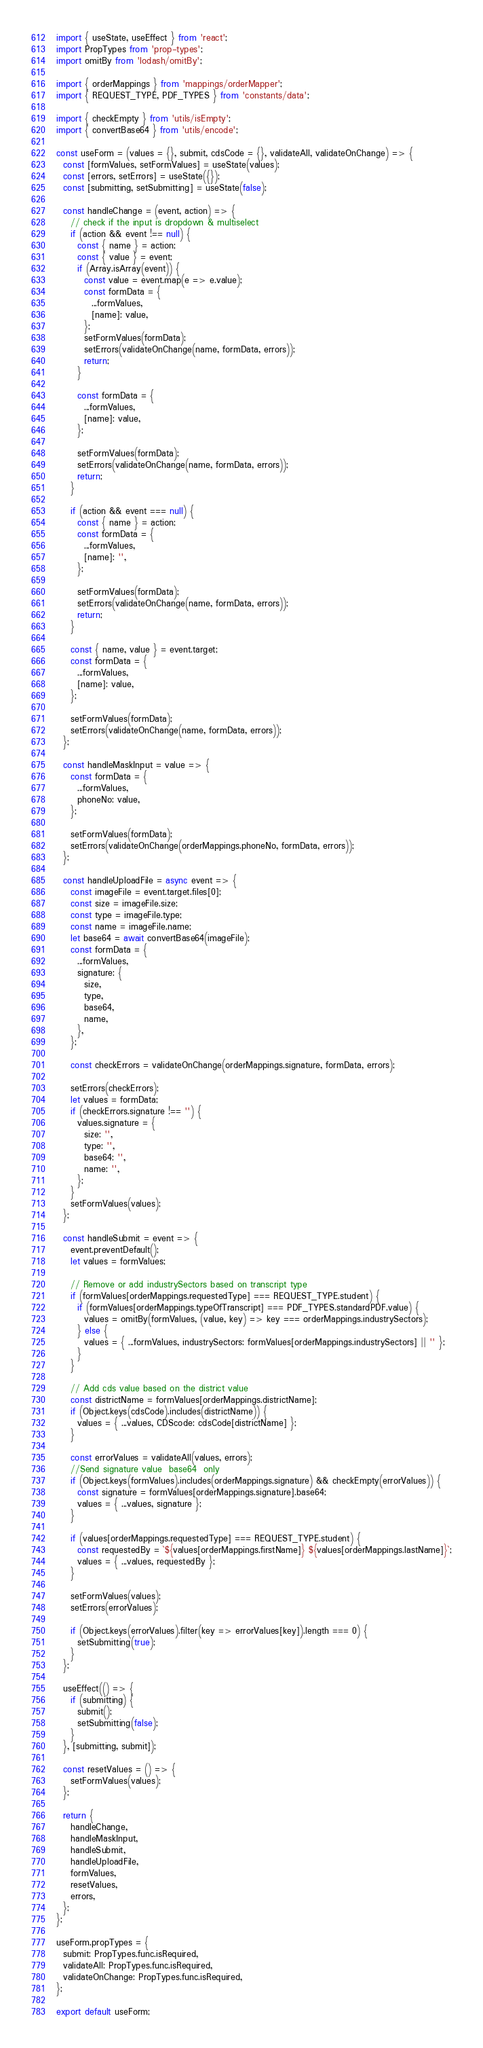Convert code to text. <code><loc_0><loc_0><loc_500><loc_500><_JavaScript_>import { useState, useEffect } from 'react';
import PropTypes from 'prop-types';
import omitBy from 'lodash/omitBy';

import { orderMappings } from 'mappings/orderMapper';
import { REQUEST_TYPE, PDF_TYPES } from 'constants/data';

import { checkEmpty } from 'utils/isEmpty';
import { convertBase64 } from 'utils/encode';

const useForm = (values = {}, submit, cdsCode = {}, validateAll, validateOnChange) => {
  const [formValues, setFormValues] = useState(values);
  const [errors, setErrors] = useState({});
  const [submitting, setSubmitting] = useState(false);

  const handleChange = (event, action) => {
    // check if the input is dropdown & multiselect
    if (action && event !== null) {
      const { name } = action;
      const { value } = event;
      if (Array.isArray(event)) {
        const value = event.map(e => e.value);
        const formData = {
          ...formValues,
          [name]: value,
        };
        setFormValues(formData);
        setErrors(validateOnChange(name, formData, errors));
        return;
      }

      const formData = {
        ...formValues,
        [name]: value,
      };

      setFormValues(formData);
      setErrors(validateOnChange(name, formData, errors));
      return;
    }

    if (action && event === null) {
      const { name } = action;
      const formData = {
        ...formValues,
        [name]: '',
      };

      setFormValues(formData);
      setErrors(validateOnChange(name, formData, errors));
      return;
    }

    const { name, value } = event.target;
    const formData = {
      ...formValues,
      [name]: value,
    };

    setFormValues(formData);
    setErrors(validateOnChange(name, formData, errors));
  };

  const handleMaskInput = value => {
    const formData = {
      ...formValues,
      phoneNo: value,
    };

    setFormValues(formData);
    setErrors(validateOnChange(orderMappings.phoneNo, formData, errors));
  };

  const handleUploadFile = async event => {
    const imageFile = event.target.files[0];
    const size = imageFile.size;
    const type = imageFile.type;
    const name = imageFile.name;
    let base64 = await convertBase64(imageFile);
    const formData = {
      ...formValues,
      signature: {
        size,
        type,
        base64,
        name,
      },
    };

    const checkErrors = validateOnChange(orderMappings.signature, formData, errors);

    setErrors(checkErrors);
    let values = formData;
    if (checkErrors.signature !== '') {
      values.signature = {
        size: '',
        type: '',
        base64: '',
        name: '',
      };
    }
    setFormValues(values);
  };

  const handleSubmit = event => {
    event.preventDefault();
    let values = formValues;

    // Remove or add industrySectors based on transcript type
    if (formValues[orderMappings.requestedType] === REQUEST_TYPE.student) {
      if (formValues[orderMappings.typeOfTranscript] === PDF_TYPES.standardPDF.value) {
        values = omitBy(formValues, (value, key) => key === orderMappings.industrySectors);
      } else {
        values = { ...formValues, industrySectors: formValues[orderMappings.industrySectors] || '' };
      }
    }

    // Add cds value based on the district value
    const districtName = formValues[orderMappings.districtName];
    if (Object.keys(cdsCode).includes(districtName)) {
      values = { ...values, CDScode: cdsCode[districtName] };
    }

    const errorValues = validateAll(values, errors);
    //Send signature value  base64  only
    if (Object.keys(formValues).includes(orderMappings.signature) && checkEmpty(errorValues)) {
      const signature = formValues[orderMappings.signature].base64;
      values = { ...values, signature };
    }

    if (values[orderMappings.requestedType] === REQUEST_TYPE.student) {
      const requestedBy = `${values[orderMappings.firstName]} ${values[orderMappings.lastName]}`;
      values = { ...values, requestedBy };
    }

    setFormValues(values);
    setErrors(errorValues);

    if (Object.keys(errorValues).filter(key => errorValues[key]).length === 0) {
      setSubmitting(true);
    }
  };

  useEffect(() => {
    if (submitting) {
      submit();
      setSubmitting(false);
    }
  }, [submitting, submit]);

  const resetValues = () => {
    setFormValues(values);
  };

  return {
    handleChange,
    handleMaskInput,
    handleSubmit,
    handleUploadFile,
    formValues,
    resetValues,
    errors,
  };
};

useForm.propTypes = {
  submit: PropTypes.func.isRequired,
  validateAll: PropTypes.func.isRequired,
  validateOnChange: PropTypes.func.isRequired,
};

export default useForm;
</code> 